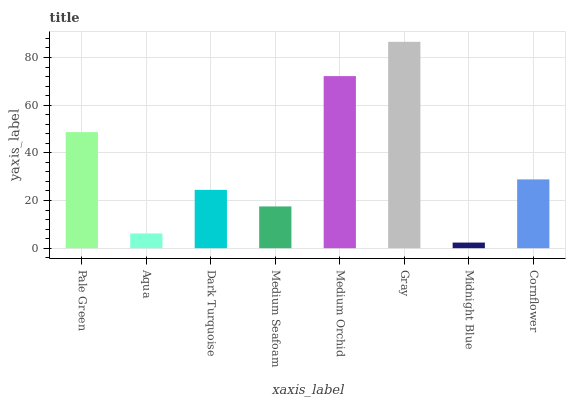Is Midnight Blue the minimum?
Answer yes or no. Yes. Is Gray the maximum?
Answer yes or no. Yes. Is Aqua the minimum?
Answer yes or no. No. Is Aqua the maximum?
Answer yes or no. No. Is Pale Green greater than Aqua?
Answer yes or no. Yes. Is Aqua less than Pale Green?
Answer yes or no. Yes. Is Aqua greater than Pale Green?
Answer yes or no. No. Is Pale Green less than Aqua?
Answer yes or no. No. Is Cornflower the high median?
Answer yes or no. Yes. Is Dark Turquoise the low median?
Answer yes or no. Yes. Is Medium Orchid the high median?
Answer yes or no. No. Is Pale Green the low median?
Answer yes or no. No. 